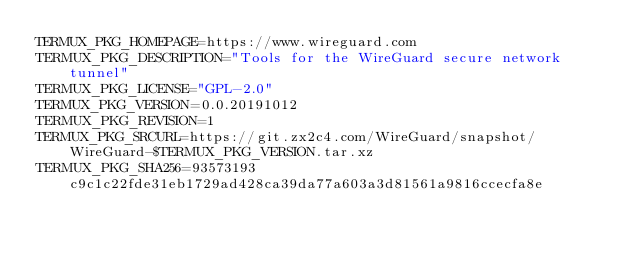<code> <loc_0><loc_0><loc_500><loc_500><_Bash_>TERMUX_PKG_HOMEPAGE=https://www.wireguard.com
TERMUX_PKG_DESCRIPTION="Tools for the WireGuard secure network tunnel"
TERMUX_PKG_LICENSE="GPL-2.0"
TERMUX_PKG_VERSION=0.0.20191012
TERMUX_PKG_REVISION=1
TERMUX_PKG_SRCURL=https://git.zx2c4.com/WireGuard/snapshot/WireGuard-$TERMUX_PKG_VERSION.tar.xz
TERMUX_PKG_SHA256=93573193c9c1c22fde31eb1729ad428ca39da77a603a3d81561a9816ccecfa8e</code> 